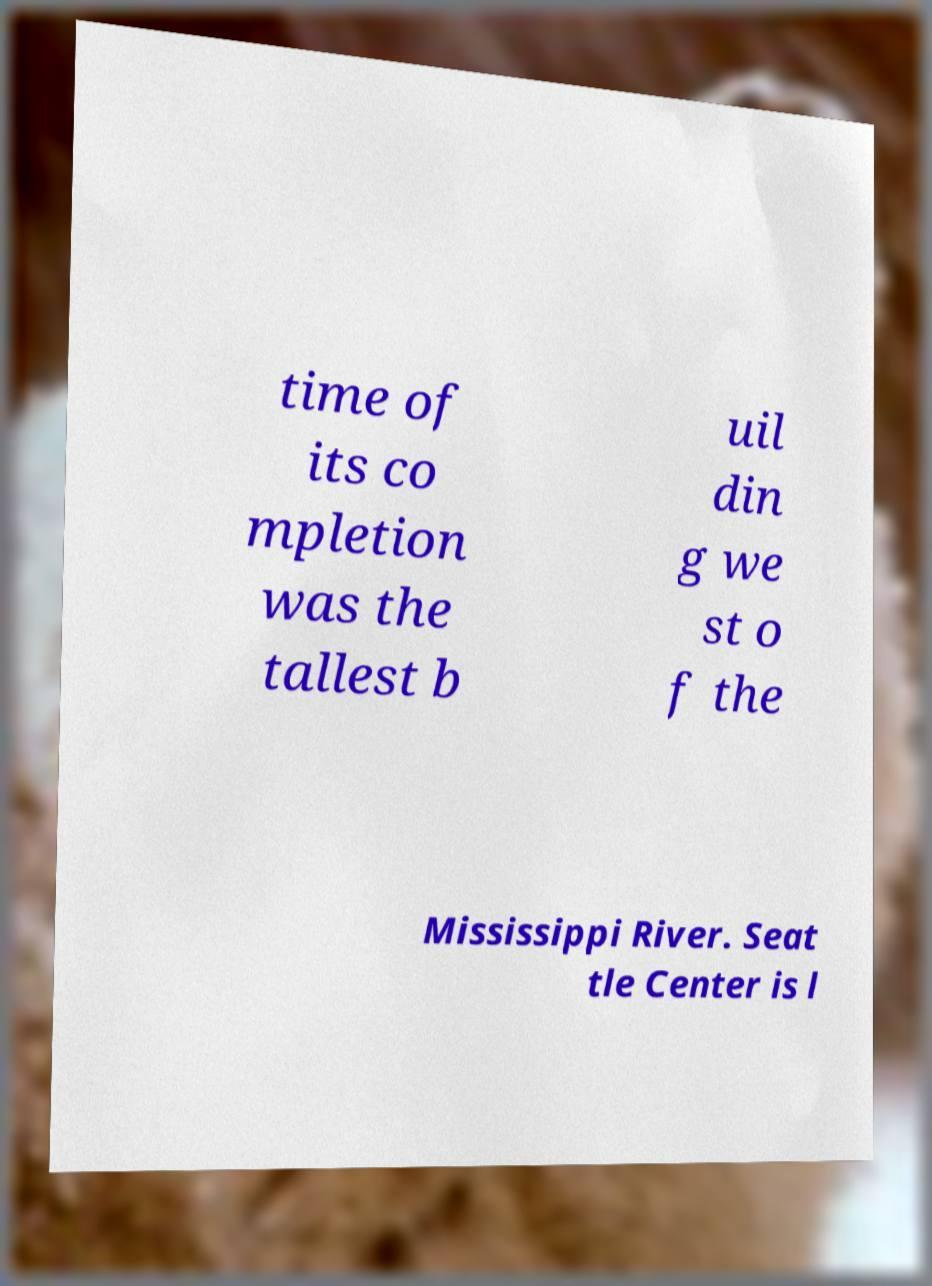Could you assist in decoding the text presented in this image and type it out clearly? time of its co mpletion was the tallest b uil din g we st o f the Mississippi River. Seat tle Center is l 